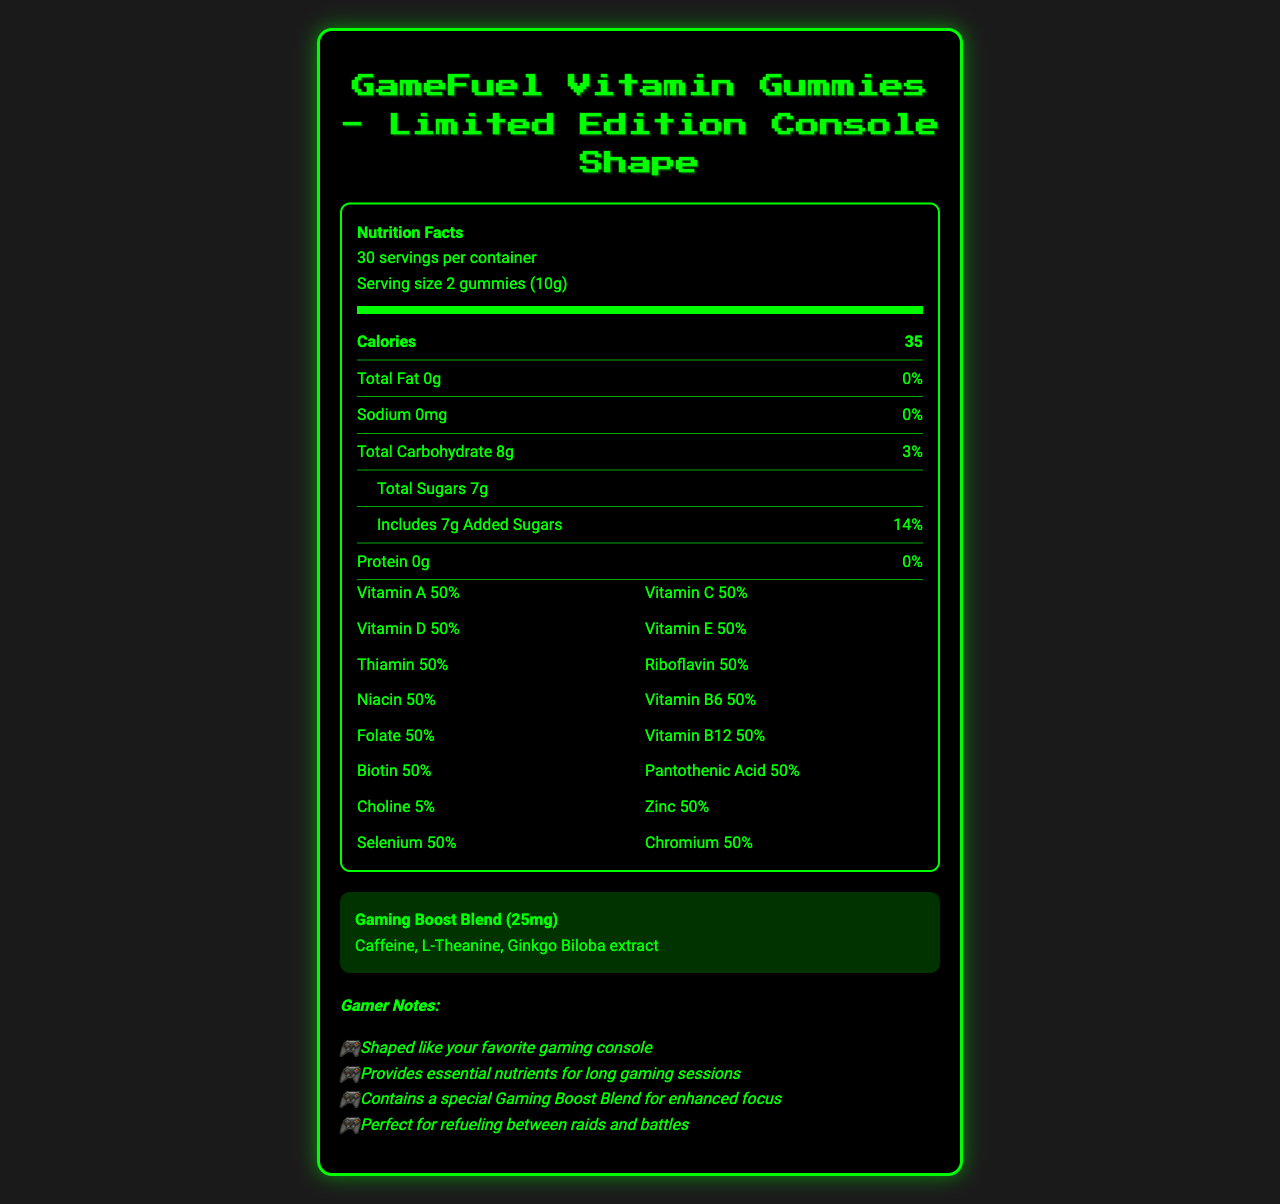what is the serving size for GameFuel Vitamin Gummies? The document states that the serving size is 2 gummies (10g).
Answer: 2 gummies (10g) how many calories are in one serving of GameFuel Vitamin Gummies? The nutrition label on the document specifies that one serving size contains 35 calories.
Answer: 35 what is the daily value percentage of Vitamin A in GameFuel Vitamin Gummies? The document lists Vitamin A at 50% daily value per serving.
Answer: 50% which ingredient in GameFuel Vitamin Gummies might cause an allergy? The allergen information section specifies that the product contains coconut.
Answer: Coconut list two vitamins that have a 50% daily value in GameFuel Vitamin Gummies. The nutrition label shows that both Vitamin C and Vitamin D have a 50% daily value per serving.
Answer: Vitamin C and Vitamin D what is the conditioning blend amount in the GameFuel Vitamin Gummies? The gaming boost blend is specified as 25mg in the document.
Answer: 25mg how many servings are in one container of GameFuel Vitamin Gummies? The document indicates there are 30 servings per container.
Answer: 30 how much protein is in one serving? The nutrition label states that there is 0g of protein per serving.
Answer: 0g what percentage of daily value does choline contribute? The document indicates choline has a 5% daily value per serving.
Answer: 5% what are the three ingredients in the Gaming Boost Blend? A. Caffeine, L-Theanine, Ginkgo Biloba B. Caffeine, Vitamin A, Choline C. L-Theanine, Vitamin C, Zinc The gaming boost blend section lists Caffeine, L-Theanine, and Ginkgo Biloba extract as ingredients.
Answer: A how many grams of total carbohydrates are in one serving? A. 5g B. 8g C. 12g D. 3g The document lists total carbohydrates as 8g per serving.
Answer: B what kind of flavors are used in the product? A. Synthetic B. Natural C. Artificial D. Mixed The document states that the product uses natural flavors.
Answer: B does the GameFuel Vitamin Gummies contain added sugars? The document indicates there are 7g of added sugars per serving.
Answer: Yes summarize the main purpose of the GameFuel Vitamin Gummies. The document emphasizes that the gummies offer vital nutrients for gamers and include a boost blend for improved focus, making it ideal for prolonged gaming periods.
Answer: Provides essential nutrients and a special Gaming Boost Blend to enhance focus during long gaming sessions. what are the ingredients of the Gaming Boost Blend? The ingredients of the Gaming Boost Blend are not specified within the provided information.
Answer: I don't know 